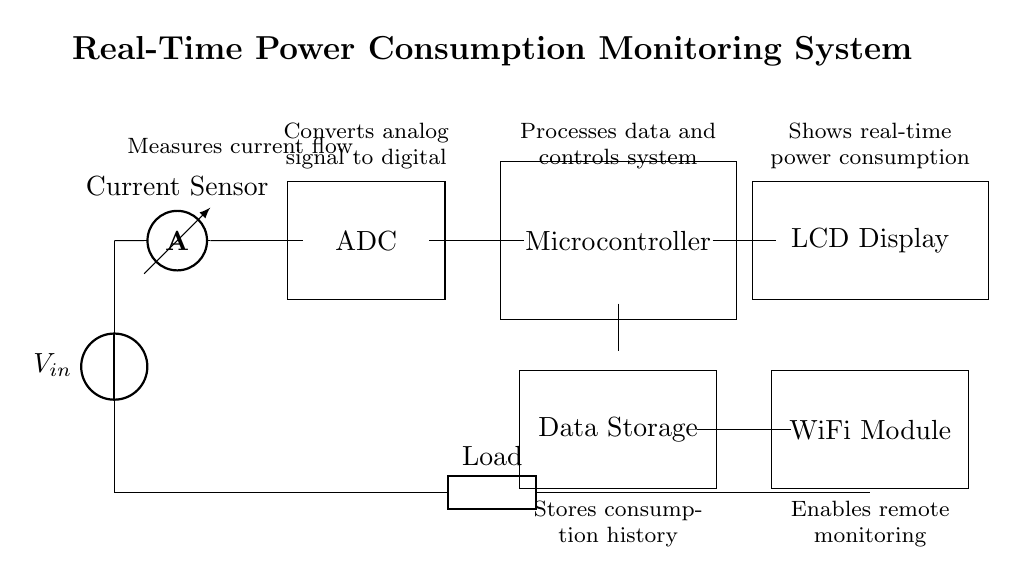What is the main component that measures the current? The main component used to measure current in this circuit is the ammeter, which is represented right after the power source. It monitors the amount of current flowing through the circuit.
Answer: ammeter What does the ADC do in this circuit? The ADC, or Analog-to-Digital Converter, converts the analog signal from the current sensor into a digital signal that the microcontroller can process. This allows for accurate measurement and further analysis of the power consumption data.
Answer: Converts analog to digital How many microcontrollers are present in the circuit? The circuit contains one microcontroller, which is noted as the central component responsible for processing the data received from the ADC and controlling the overall system functions.
Answer: one What is the purpose of the WiFi module? The WiFi module enables remote monitoring of power consumption by allowing the system to send data wirelessly to other devices or servers, making it easy to access consumption history and real-time metrics from anywhere.
Answer: Remote monitoring What would happen if the current sensor fails? If the current sensor fails, the ammeter will not accurately measure the current flow, leading to incorrect data being sent to the ADC and thus affecting the entire monitoring system's capability to display real-time power consumption accurately.
Answer: Data becomes inaccurate What is the connection between the display and the microcontroller? The LCD display is connected to the microcontroller, which sends processed data from the ADC to the display so that users can visually see the real-time power consumption information. This connection is essential for the monitoring system's functionality.
Answer: Displays power consumption 